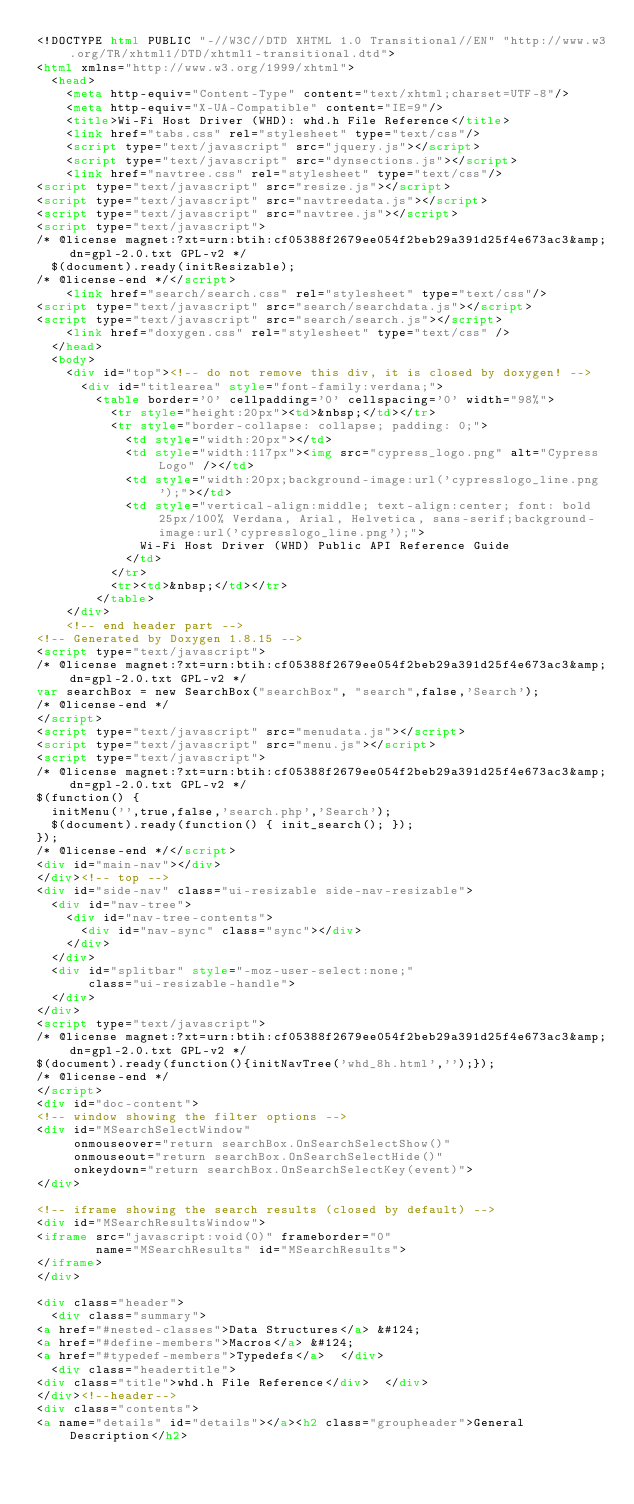Convert code to text. <code><loc_0><loc_0><loc_500><loc_500><_HTML_><!DOCTYPE html PUBLIC "-//W3C//DTD XHTML 1.0 Transitional//EN" "http://www.w3.org/TR/xhtml1/DTD/xhtml1-transitional.dtd">
<html xmlns="http://www.w3.org/1999/xhtml">
  <head>
    <meta http-equiv="Content-Type" content="text/xhtml;charset=UTF-8"/>
    <meta http-equiv="X-UA-Compatible" content="IE=9"/>
    <title>Wi-Fi Host Driver (WHD): whd.h File Reference</title>
    <link href="tabs.css" rel="stylesheet" type="text/css"/>
    <script type="text/javascript" src="jquery.js"></script>
    <script type="text/javascript" src="dynsections.js"></script>
    <link href="navtree.css" rel="stylesheet" type="text/css"/>
<script type="text/javascript" src="resize.js"></script>
<script type="text/javascript" src="navtreedata.js"></script>
<script type="text/javascript" src="navtree.js"></script>
<script type="text/javascript">
/* @license magnet:?xt=urn:btih:cf05388f2679ee054f2beb29a391d25f4e673ac3&amp;dn=gpl-2.0.txt GPL-v2 */
  $(document).ready(initResizable);
/* @license-end */</script>
    <link href="search/search.css" rel="stylesheet" type="text/css"/>
<script type="text/javascript" src="search/searchdata.js"></script>
<script type="text/javascript" src="search/search.js"></script>
    <link href="doxygen.css" rel="stylesheet" type="text/css" />
  </head>
  <body>
    <div id="top"><!-- do not remove this div, it is closed by doxygen! -->
      <div id="titlearea" style="font-family:verdana;">
        <table border='0' cellpadding='0' cellspacing='0' width="98%">
          <tr style="height:20px"><td>&nbsp;</td></tr>
          <tr style="border-collapse: collapse; padding: 0;">
            <td style="width:20px"></td>
            <td style="width:117px"><img src="cypress_logo.png" alt="Cypress Logo" /></td>
            <td style="width:20px;background-image:url('cypresslogo_line.png');"></td>
            <td style="vertical-align:middle; text-align:center; font: bold 25px/100% Verdana, Arial, Helvetica, sans-serif;background-image:url('cypresslogo_line.png');">
              Wi-Fi Host Driver (WHD) Public API Reference Guide
            </td>
          </tr>
          <tr><td>&nbsp;</td></tr>
        </table>
    </div>
    <!-- end header part -->
<!-- Generated by Doxygen 1.8.15 -->
<script type="text/javascript">
/* @license magnet:?xt=urn:btih:cf05388f2679ee054f2beb29a391d25f4e673ac3&amp;dn=gpl-2.0.txt GPL-v2 */
var searchBox = new SearchBox("searchBox", "search",false,'Search');
/* @license-end */
</script>
<script type="text/javascript" src="menudata.js"></script>
<script type="text/javascript" src="menu.js"></script>
<script type="text/javascript">
/* @license magnet:?xt=urn:btih:cf05388f2679ee054f2beb29a391d25f4e673ac3&amp;dn=gpl-2.0.txt GPL-v2 */
$(function() {
  initMenu('',true,false,'search.php','Search');
  $(document).ready(function() { init_search(); });
});
/* @license-end */</script>
<div id="main-nav"></div>
</div><!-- top -->
<div id="side-nav" class="ui-resizable side-nav-resizable">
  <div id="nav-tree">
    <div id="nav-tree-contents">
      <div id="nav-sync" class="sync"></div>
    </div>
  </div>
  <div id="splitbar" style="-moz-user-select:none;"
       class="ui-resizable-handle">
  </div>
</div>
<script type="text/javascript">
/* @license magnet:?xt=urn:btih:cf05388f2679ee054f2beb29a391d25f4e673ac3&amp;dn=gpl-2.0.txt GPL-v2 */
$(document).ready(function(){initNavTree('whd_8h.html','');});
/* @license-end */
</script>
<div id="doc-content">
<!-- window showing the filter options -->
<div id="MSearchSelectWindow"
     onmouseover="return searchBox.OnSearchSelectShow()"
     onmouseout="return searchBox.OnSearchSelectHide()"
     onkeydown="return searchBox.OnSearchSelectKey(event)">
</div>

<!-- iframe showing the search results (closed by default) -->
<div id="MSearchResultsWindow">
<iframe src="javascript:void(0)" frameborder="0"
        name="MSearchResults" id="MSearchResults">
</iframe>
</div>

<div class="header">
  <div class="summary">
<a href="#nested-classes">Data Structures</a> &#124;
<a href="#define-members">Macros</a> &#124;
<a href="#typedef-members">Typedefs</a>  </div>
  <div class="headertitle">
<div class="title">whd.h File Reference</div>  </div>
</div><!--header-->
<div class="contents">
<a name="details" id="details"></a><h2 class="groupheader">General Description</h2></code> 